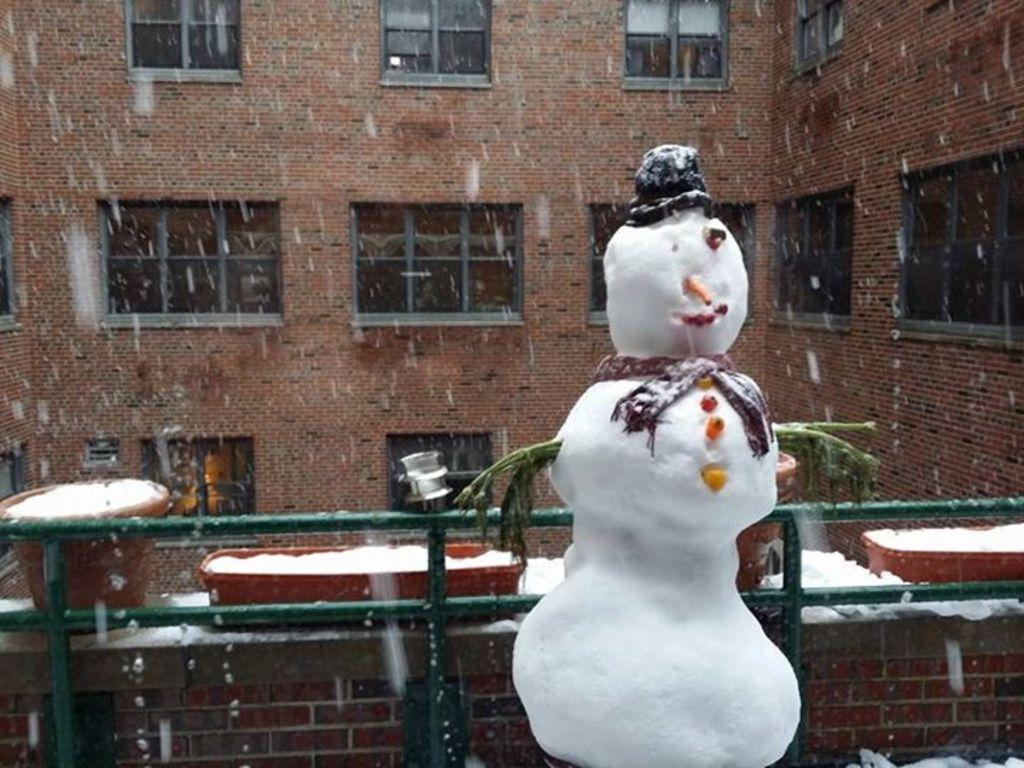What is the main subject of the image? There is a snowman in the image. What else can be seen in the image besides the snowman? There are pots with snow and rods in the image. What is the background of the image? There is a building with windows in the background of the image. What is the purpose of the rods in the image? The purpose of the rods is not specified in the facts, but they could be used for decoration or support. Can you see any cherries on the snowman in the image? There are no cherries present in the image; the snowman is made of snow and other decorative elements. 